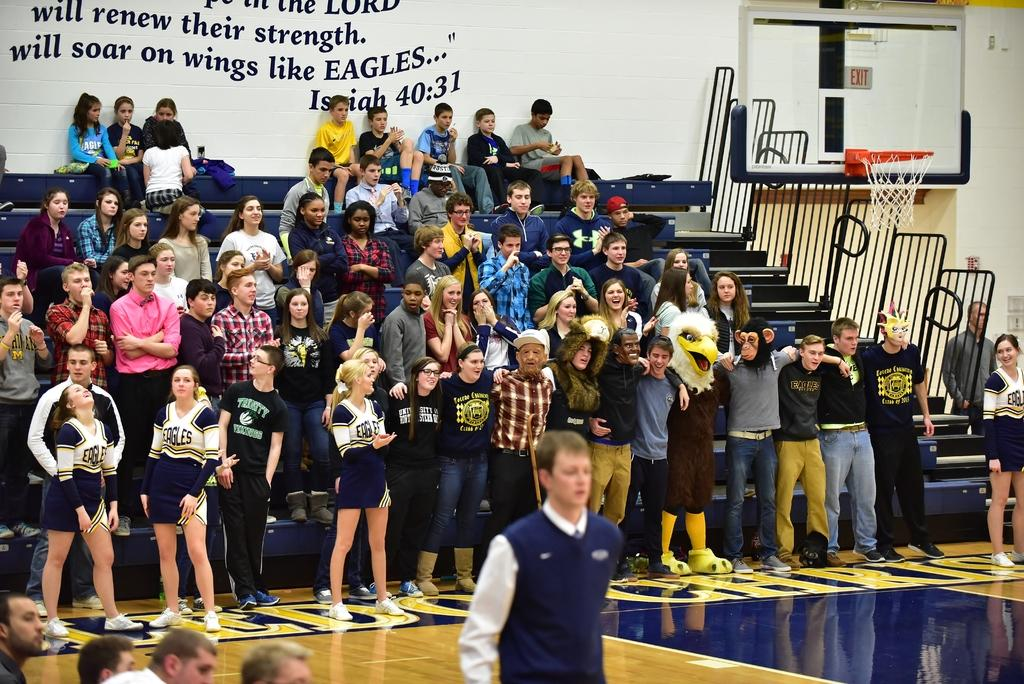Provide a one-sentence caption for the provided image. The Eagles fans and cheerleaders had a backdrop of the Bible verse Isaiah 40:31. 